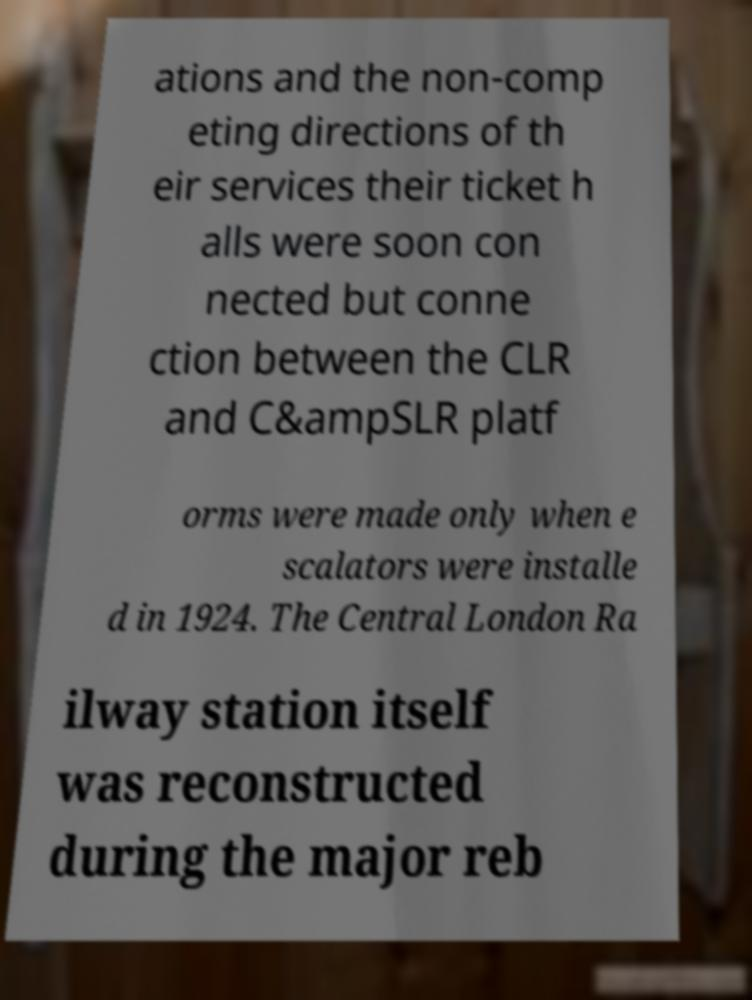Could you assist in decoding the text presented in this image and type it out clearly? ations and the non-comp eting directions of th eir services their ticket h alls were soon con nected but conne ction between the CLR and C&ampSLR platf orms were made only when e scalators were installe d in 1924. The Central London Ra ilway station itself was reconstructed during the major reb 